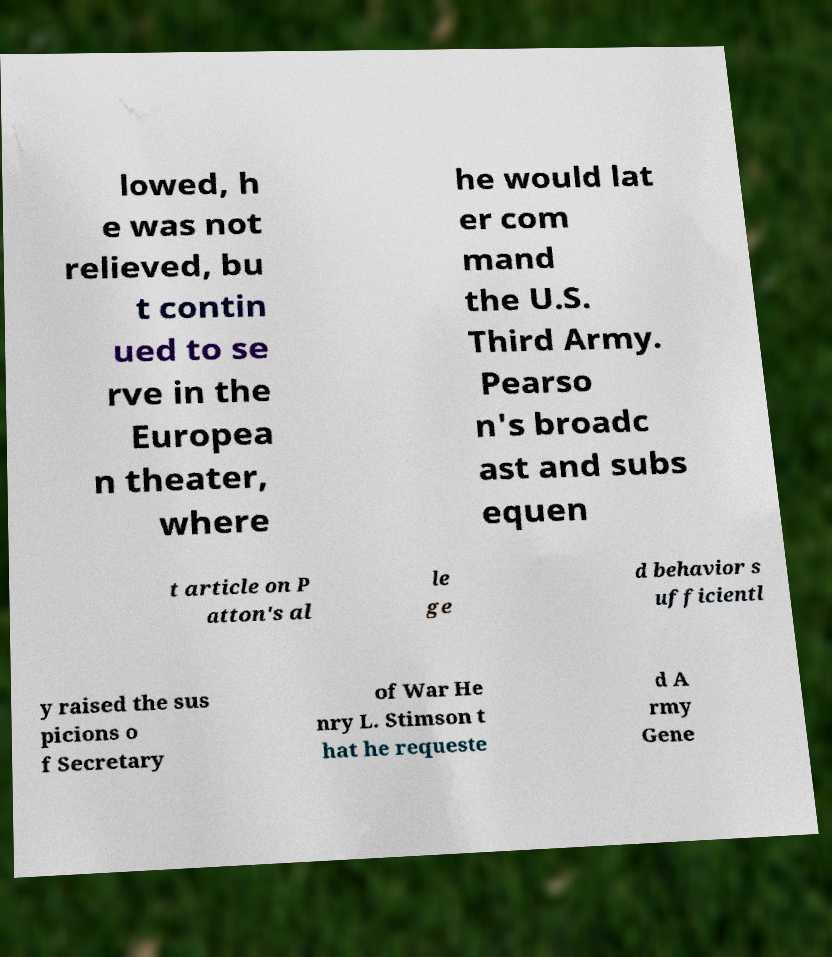Can you read and provide the text displayed in the image?This photo seems to have some interesting text. Can you extract and type it out for me? lowed, h e was not relieved, bu t contin ued to se rve in the Europea n theater, where he would lat er com mand the U.S. Third Army. Pearso n's broadc ast and subs equen t article on P atton's al le ge d behavior s ufficientl y raised the sus picions o f Secretary of War He nry L. Stimson t hat he requeste d A rmy Gene 